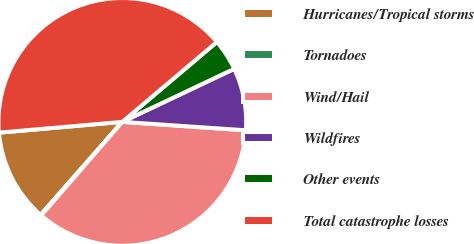Convert chart. <chart><loc_0><loc_0><loc_500><loc_500><pie_chart><fcel>Hurricanes/Tropical storms<fcel>Tornadoes<fcel>Wind/Hail<fcel>Wildfires<fcel>Other events<fcel>Total catastrophe losses<nl><fcel>12.14%<fcel>0.11%<fcel>35.28%<fcel>8.13%<fcel>4.12%<fcel>40.22%<nl></chart> 